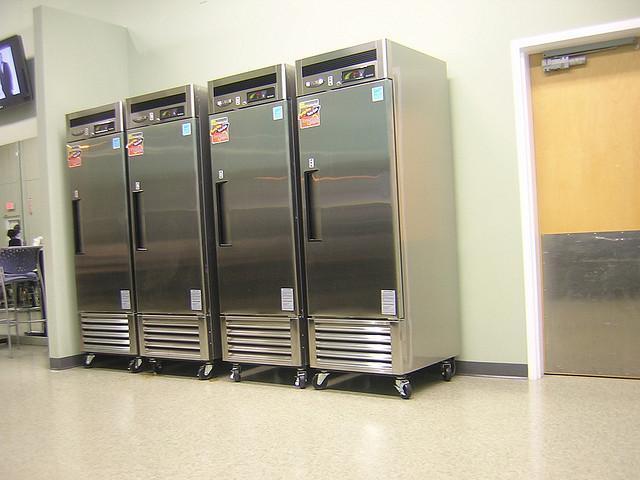How many refrigerators are depicted in this scene?
Give a very brief answer. 4. How many refrigerators are visible?
Give a very brief answer. 4. 